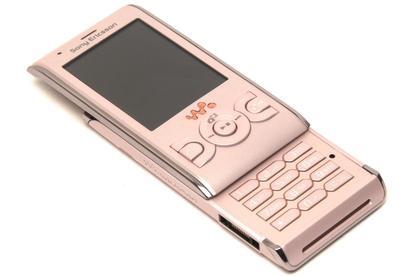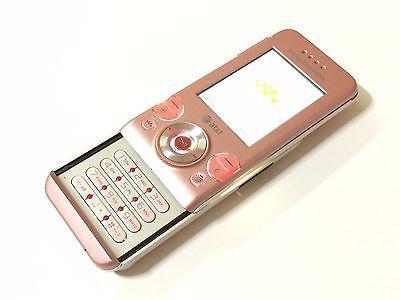The first image is the image on the left, the second image is the image on the right. Given the left and right images, does the statement "Hello Kitty is on at least one of the phones." hold true? Answer yes or no. No. The first image is the image on the left, the second image is the image on the right. Considering the images on both sides, is "The screen of one of the phones is off." valid? Answer yes or no. Yes. 